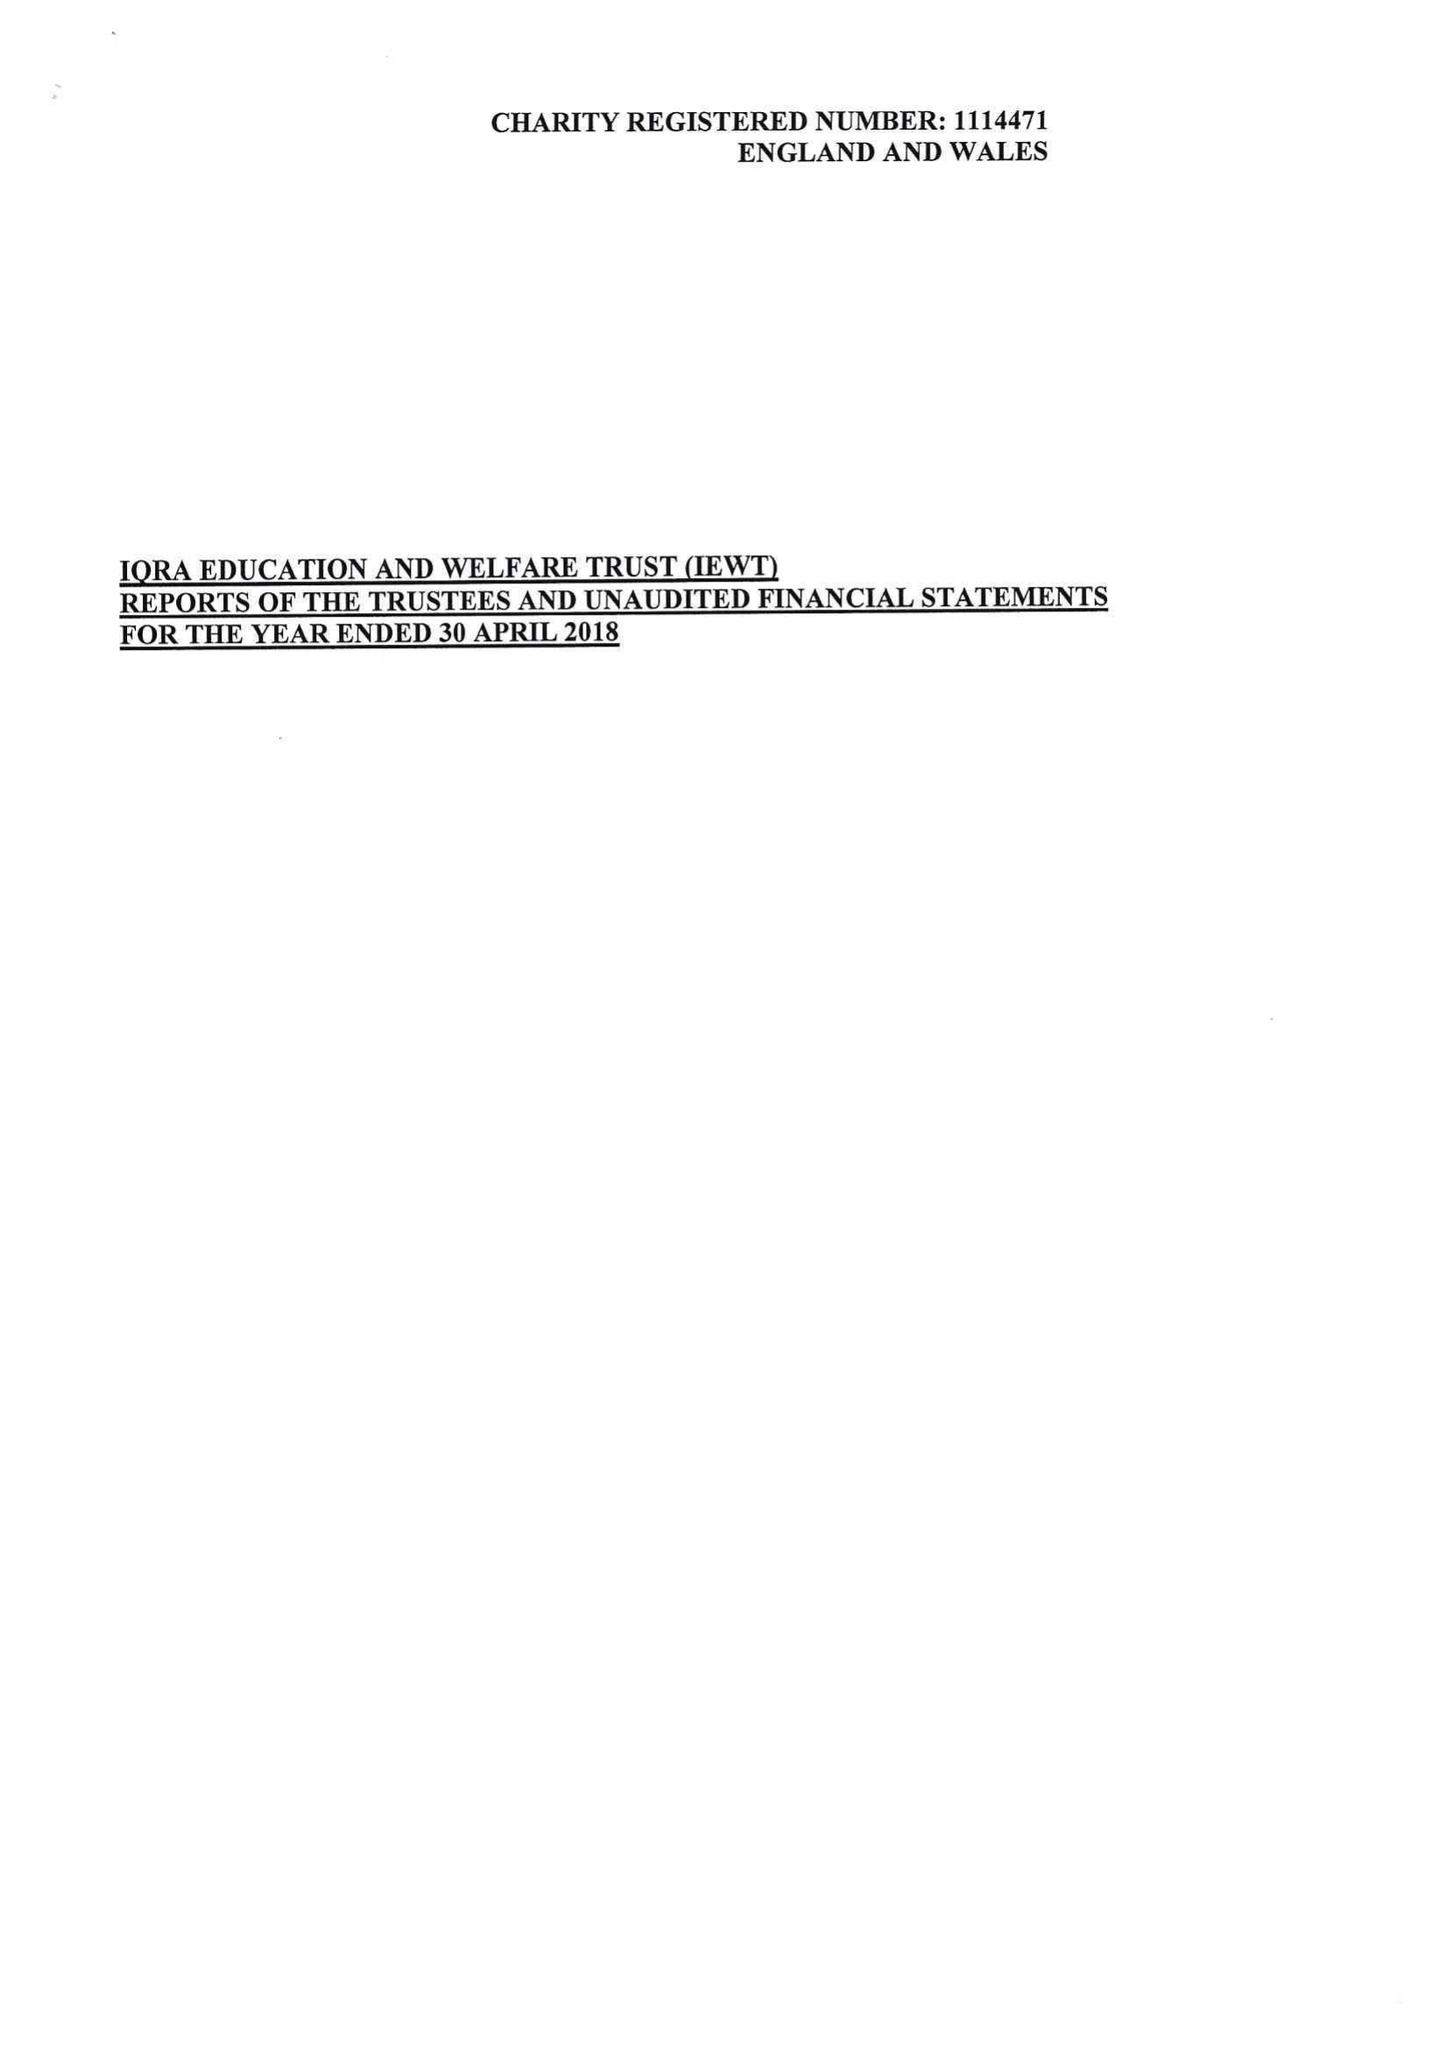What is the value for the address__street_line?
Answer the question using a single word or phrase. 319 WATERLOO STREET 